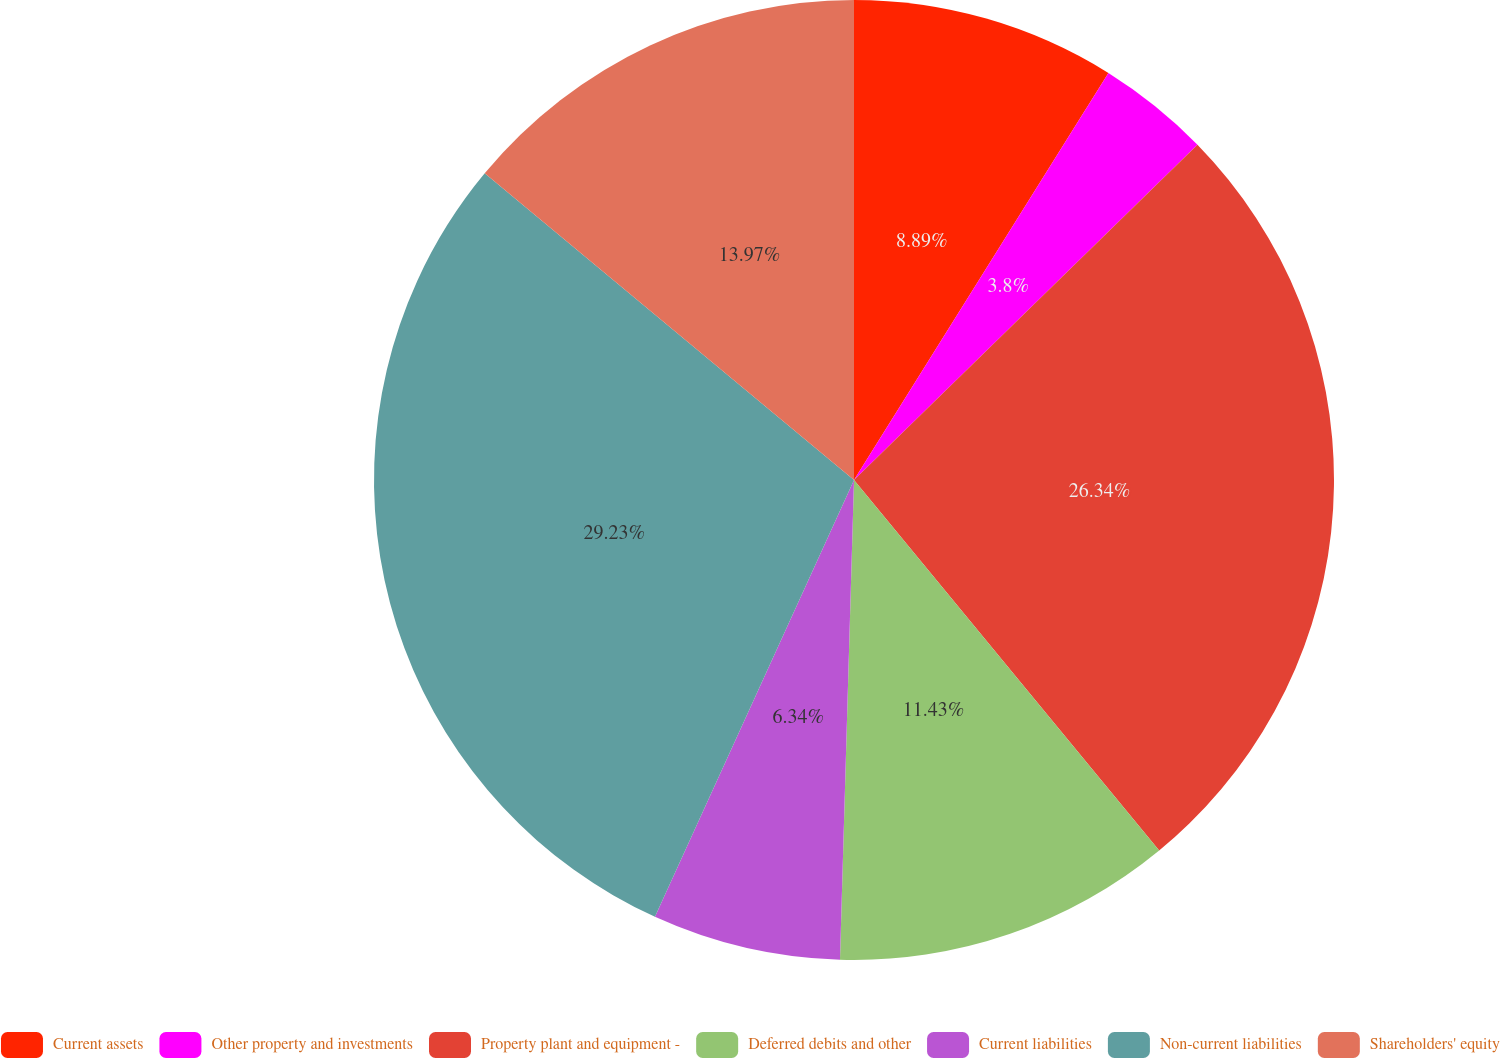Convert chart. <chart><loc_0><loc_0><loc_500><loc_500><pie_chart><fcel>Current assets<fcel>Other property and investments<fcel>Property plant and equipment -<fcel>Deferred debits and other<fcel>Current liabilities<fcel>Non-current liabilities<fcel>Shareholders' equity<nl><fcel>8.89%<fcel>3.8%<fcel>26.34%<fcel>11.43%<fcel>6.34%<fcel>29.22%<fcel>13.97%<nl></chart> 